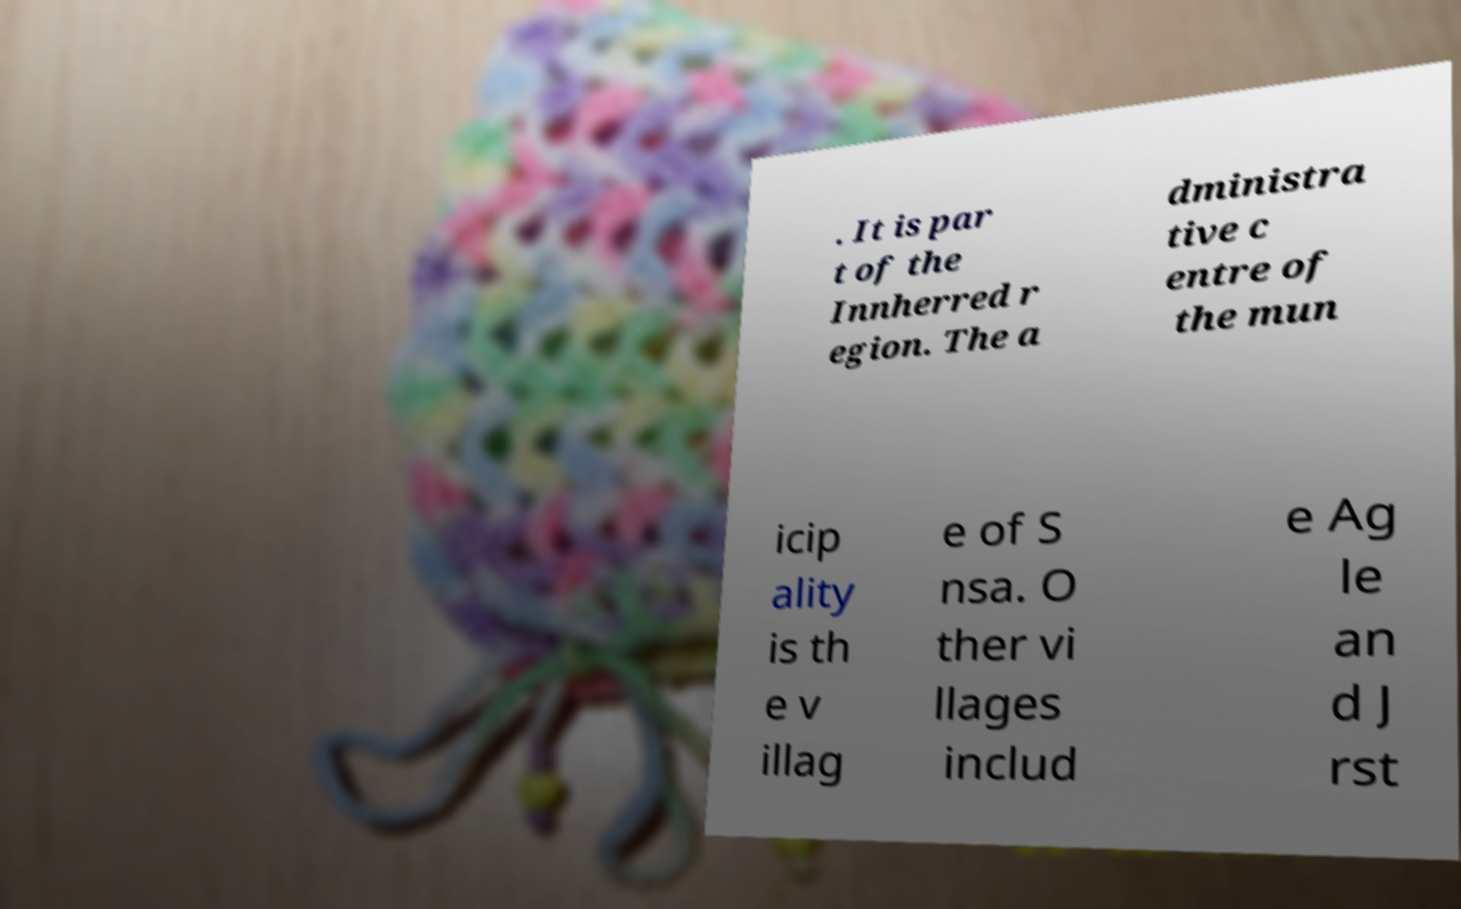Can you read and provide the text displayed in the image?This photo seems to have some interesting text. Can you extract and type it out for me? . It is par t of the Innherred r egion. The a dministra tive c entre of the mun icip ality is th e v illag e of S nsa. O ther vi llages includ e Ag le an d J rst 